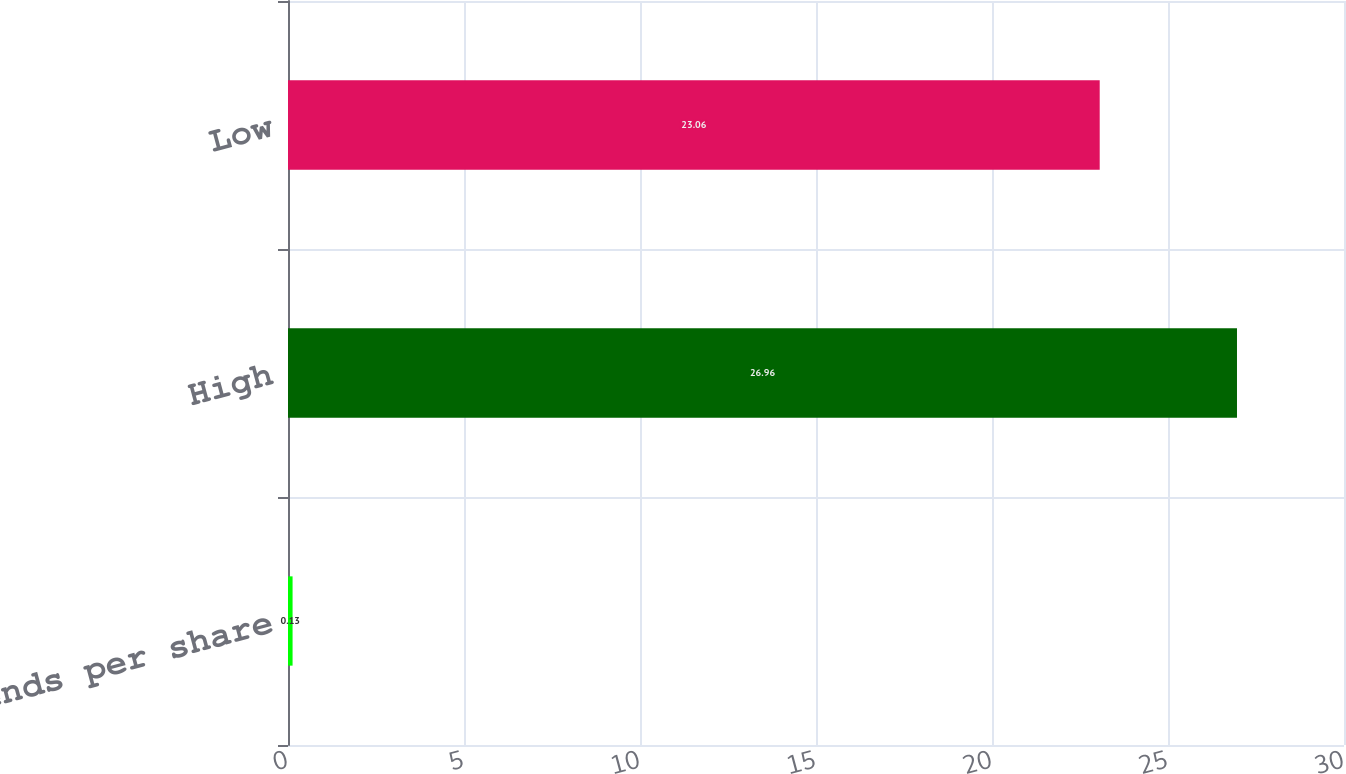Convert chart. <chart><loc_0><loc_0><loc_500><loc_500><bar_chart><fcel>Dividends per share<fcel>High<fcel>Low<nl><fcel>0.13<fcel>26.96<fcel>23.06<nl></chart> 